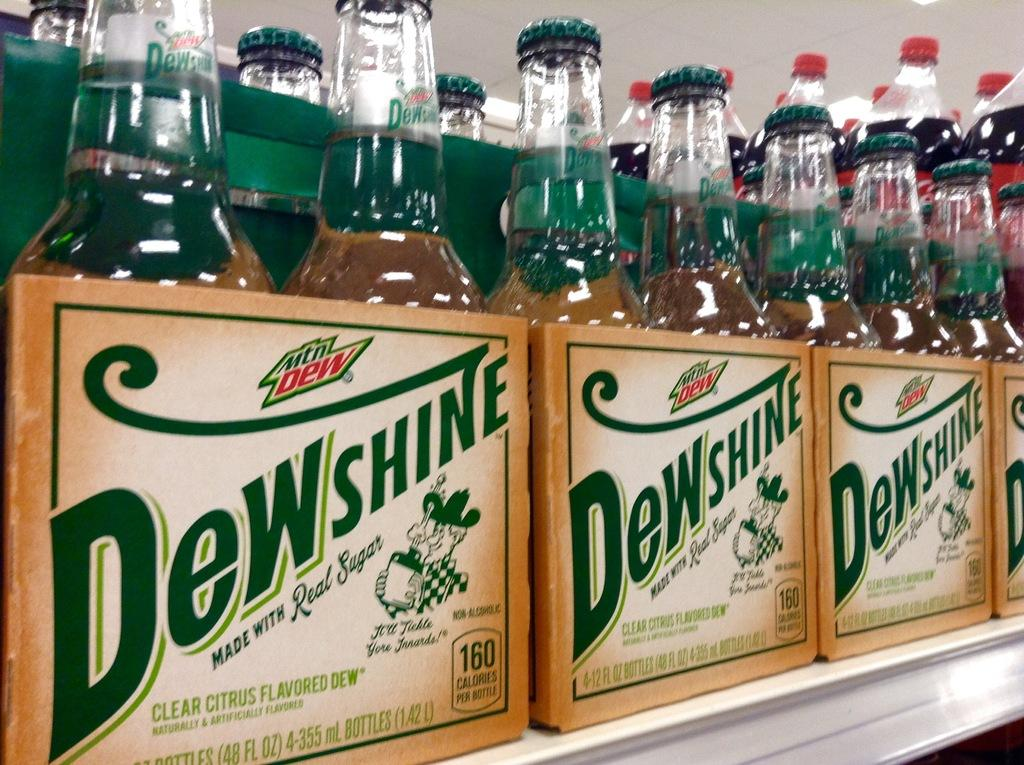<image>
Offer a succinct explanation of the picture presented. row of mountain dew dewshine on a shelf 